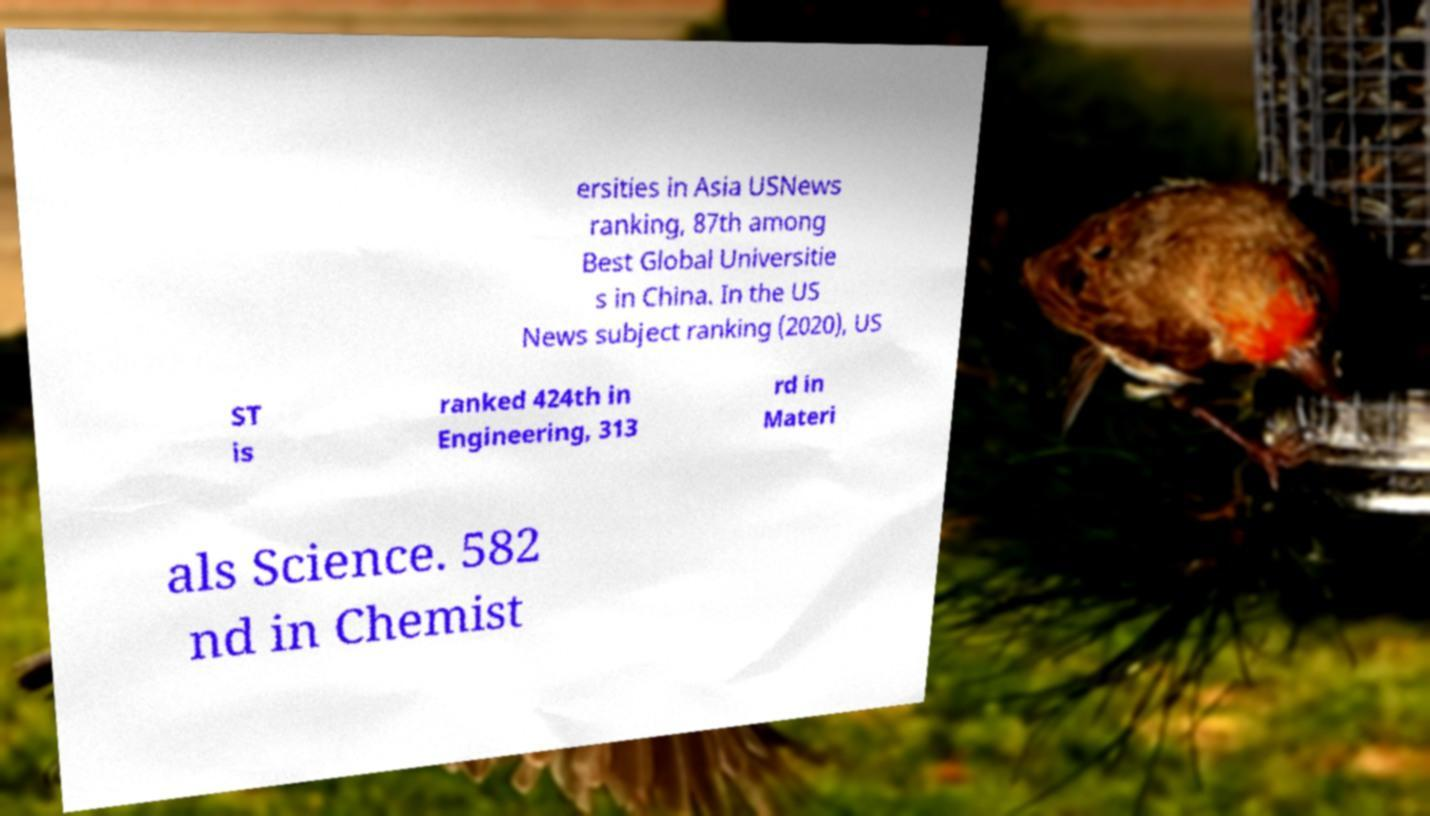What messages or text are displayed in this image? I need them in a readable, typed format. ersities in Asia USNews ranking, 87th among Best Global Universitie s in China. In the US News subject ranking (2020), US ST is ranked 424th in Engineering, 313 rd in Materi als Science. 582 nd in Chemist 